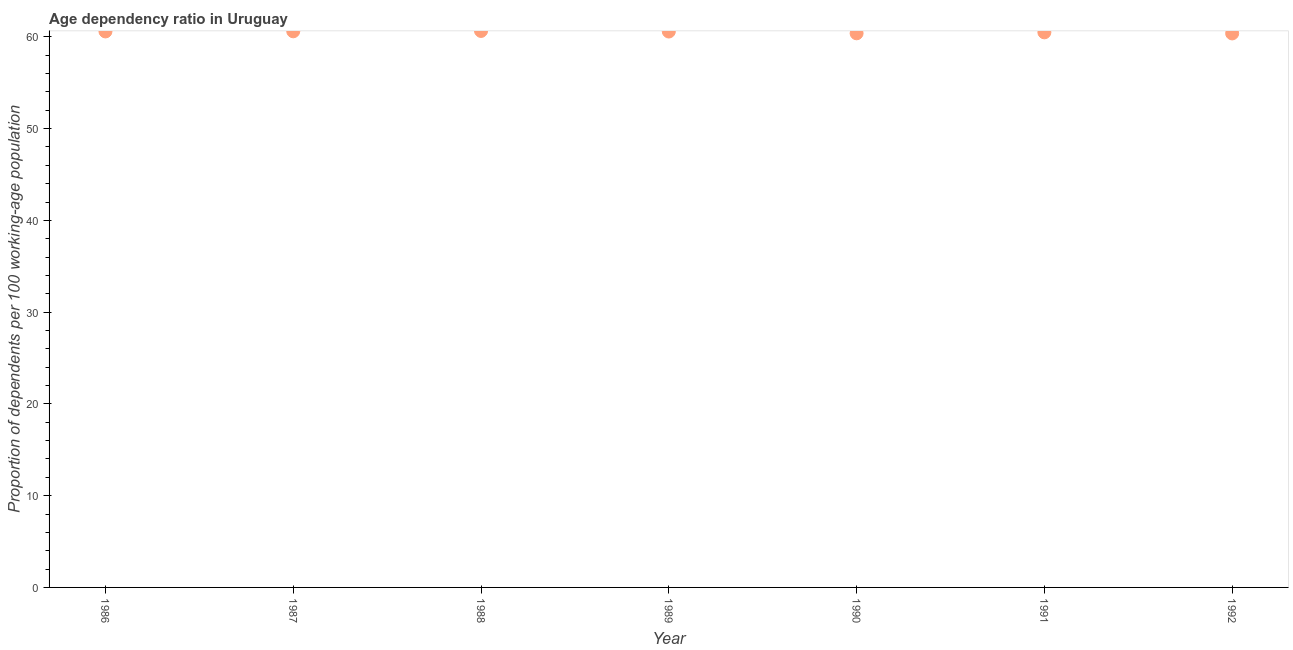What is the age dependency ratio in 1989?
Keep it short and to the point. 60.58. Across all years, what is the maximum age dependency ratio?
Give a very brief answer. 60.65. Across all years, what is the minimum age dependency ratio?
Ensure brevity in your answer.  60.38. In which year was the age dependency ratio maximum?
Ensure brevity in your answer.  1988. What is the sum of the age dependency ratio?
Make the answer very short. 423.68. What is the difference between the age dependency ratio in 1988 and 1992?
Offer a very short reply. 0.27. What is the average age dependency ratio per year?
Offer a very short reply. 60.53. What is the median age dependency ratio?
Give a very brief answer. 60.58. In how many years, is the age dependency ratio greater than 20 ?
Keep it short and to the point. 7. What is the ratio of the age dependency ratio in 1986 to that in 1991?
Provide a short and direct response. 1. Is the difference between the age dependency ratio in 1990 and 1992 greater than the difference between any two years?
Your answer should be very brief. No. What is the difference between the highest and the second highest age dependency ratio?
Your response must be concise. 0.04. What is the difference between the highest and the lowest age dependency ratio?
Your response must be concise. 0.27. In how many years, is the age dependency ratio greater than the average age dependency ratio taken over all years?
Your answer should be compact. 4. How many years are there in the graph?
Ensure brevity in your answer.  7. What is the difference between two consecutive major ticks on the Y-axis?
Your response must be concise. 10. Does the graph contain grids?
Offer a terse response. No. What is the title of the graph?
Offer a terse response. Age dependency ratio in Uruguay. What is the label or title of the Y-axis?
Ensure brevity in your answer.  Proportion of dependents per 100 working-age population. What is the Proportion of dependents per 100 working-age population in 1986?
Ensure brevity in your answer.  60.59. What is the Proportion of dependents per 100 working-age population in 1987?
Your response must be concise. 60.61. What is the Proportion of dependents per 100 working-age population in 1988?
Your answer should be compact. 60.65. What is the Proportion of dependents per 100 working-age population in 1989?
Offer a very short reply. 60.58. What is the Proportion of dependents per 100 working-age population in 1990?
Keep it short and to the point. 60.39. What is the Proportion of dependents per 100 working-age population in 1991?
Offer a terse response. 60.49. What is the Proportion of dependents per 100 working-age population in 1992?
Your answer should be compact. 60.38. What is the difference between the Proportion of dependents per 100 working-age population in 1986 and 1987?
Keep it short and to the point. -0.01. What is the difference between the Proportion of dependents per 100 working-age population in 1986 and 1988?
Your answer should be compact. -0.05. What is the difference between the Proportion of dependents per 100 working-age population in 1986 and 1989?
Offer a very short reply. 0.01. What is the difference between the Proportion of dependents per 100 working-age population in 1986 and 1990?
Keep it short and to the point. 0.2. What is the difference between the Proportion of dependents per 100 working-age population in 1986 and 1991?
Offer a terse response. 0.1. What is the difference between the Proportion of dependents per 100 working-age population in 1986 and 1992?
Keep it short and to the point. 0.22. What is the difference between the Proportion of dependents per 100 working-age population in 1987 and 1988?
Keep it short and to the point. -0.04. What is the difference between the Proportion of dependents per 100 working-age population in 1987 and 1989?
Provide a succinct answer. 0.02. What is the difference between the Proportion of dependents per 100 working-age population in 1987 and 1990?
Give a very brief answer. 0.22. What is the difference between the Proportion of dependents per 100 working-age population in 1987 and 1991?
Provide a succinct answer. 0.11. What is the difference between the Proportion of dependents per 100 working-age population in 1987 and 1992?
Your response must be concise. 0.23. What is the difference between the Proportion of dependents per 100 working-age population in 1988 and 1989?
Offer a very short reply. 0.06. What is the difference between the Proportion of dependents per 100 working-age population in 1988 and 1990?
Ensure brevity in your answer.  0.26. What is the difference between the Proportion of dependents per 100 working-age population in 1988 and 1991?
Provide a succinct answer. 0.15. What is the difference between the Proportion of dependents per 100 working-age population in 1988 and 1992?
Your answer should be very brief. 0.27. What is the difference between the Proportion of dependents per 100 working-age population in 1989 and 1990?
Keep it short and to the point. 0.19. What is the difference between the Proportion of dependents per 100 working-age population in 1989 and 1991?
Your answer should be very brief. 0.09. What is the difference between the Proportion of dependents per 100 working-age population in 1989 and 1992?
Your answer should be very brief. 0.21. What is the difference between the Proportion of dependents per 100 working-age population in 1990 and 1991?
Your answer should be compact. -0.1. What is the difference between the Proportion of dependents per 100 working-age population in 1990 and 1992?
Ensure brevity in your answer.  0.01. What is the difference between the Proportion of dependents per 100 working-age population in 1991 and 1992?
Your answer should be very brief. 0.12. What is the ratio of the Proportion of dependents per 100 working-age population in 1986 to that in 1987?
Keep it short and to the point. 1. What is the ratio of the Proportion of dependents per 100 working-age population in 1986 to that in 1988?
Your answer should be very brief. 1. What is the ratio of the Proportion of dependents per 100 working-age population in 1986 to that in 1989?
Ensure brevity in your answer.  1. What is the ratio of the Proportion of dependents per 100 working-age population in 1986 to that in 1992?
Your answer should be compact. 1. What is the ratio of the Proportion of dependents per 100 working-age population in 1987 to that in 1989?
Keep it short and to the point. 1. What is the ratio of the Proportion of dependents per 100 working-age population in 1988 to that in 1990?
Make the answer very short. 1. What is the ratio of the Proportion of dependents per 100 working-age population in 1988 to that in 1991?
Provide a succinct answer. 1. What is the ratio of the Proportion of dependents per 100 working-age population in 1989 to that in 1991?
Provide a short and direct response. 1. What is the ratio of the Proportion of dependents per 100 working-age population in 1989 to that in 1992?
Offer a terse response. 1. What is the ratio of the Proportion of dependents per 100 working-age population in 1990 to that in 1991?
Keep it short and to the point. 1. What is the ratio of the Proportion of dependents per 100 working-age population in 1990 to that in 1992?
Make the answer very short. 1. 